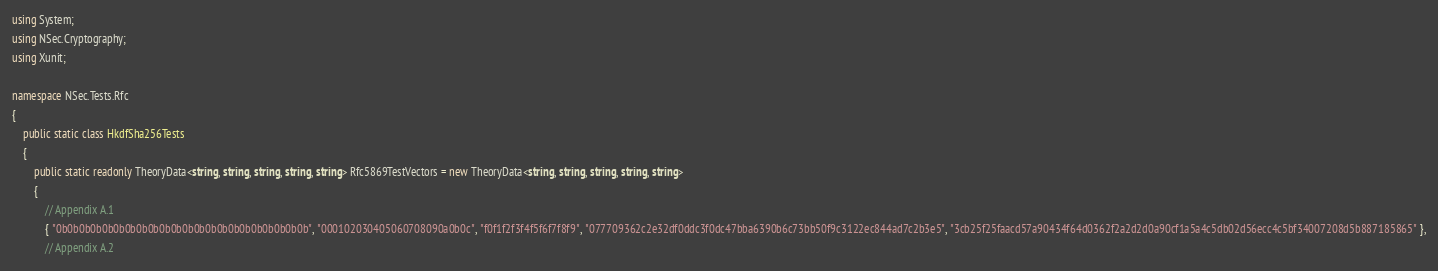Convert code to text. <code><loc_0><loc_0><loc_500><loc_500><_C#_>using System;
using NSec.Cryptography;
using Xunit;

namespace NSec.Tests.Rfc
{
    public static class HkdfSha256Tests
    {
        public static readonly TheoryData<string, string, string, string, string> Rfc5869TestVectors = new TheoryData<string, string, string, string, string>
        {
            // Appendix A.1
            { "0b0b0b0b0b0b0b0b0b0b0b0b0b0b0b0b0b0b0b0b0b0b", "000102030405060708090a0b0c", "f0f1f2f3f4f5f6f7f8f9", "077709362c2e32df0ddc3f0dc47bba6390b6c73bb50f9c3122ec844ad7c2b3e5", "3cb25f25faacd57a90434f64d0362f2a2d2d0a90cf1a5a4c5db02d56ecc4c5bf34007208d5b887185865" },
            // Appendix A.2</code> 